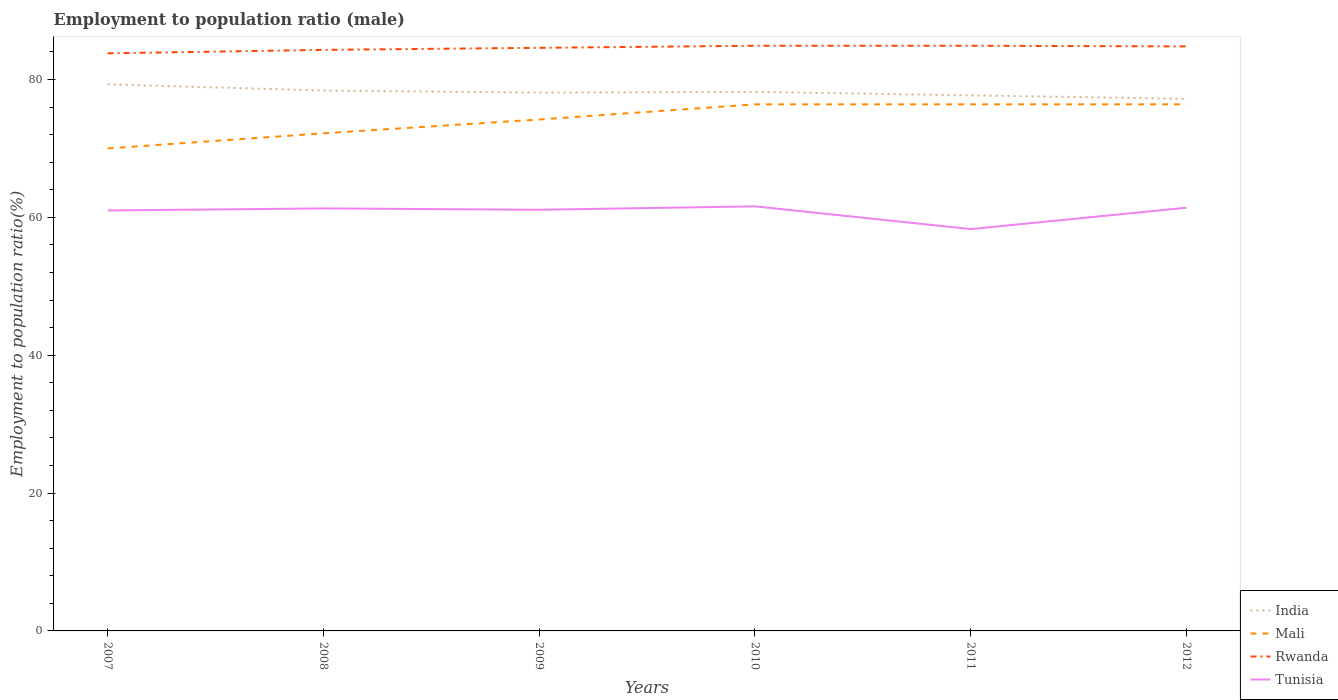How many different coloured lines are there?
Your answer should be very brief. 4. Across all years, what is the maximum employment to population ratio in Mali?
Offer a terse response. 70. In which year was the employment to population ratio in India maximum?
Give a very brief answer. 2012. What is the total employment to population ratio in India in the graph?
Offer a very short reply. 1.2. What is the difference between the highest and the second highest employment to population ratio in Mali?
Provide a short and direct response. 6.4. Is the employment to population ratio in Mali strictly greater than the employment to population ratio in India over the years?
Give a very brief answer. Yes. What is the difference between two consecutive major ticks on the Y-axis?
Your answer should be compact. 20. Are the values on the major ticks of Y-axis written in scientific E-notation?
Give a very brief answer. No. Does the graph contain any zero values?
Provide a succinct answer. No. Does the graph contain grids?
Provide a short and direct response. No. Where does the legend appear in the graph?
Provide a short and direct response. Bottom right. What is the title of the graph?
Your answer should be compact. Employment to population ratio (male). What is the label or title of the X-axis?
Offer a very short reply. Years. What is the Employment to population ratio(%) of India in 2007?
Ensure brevity in your answer.  79.3. What is the Employment to population ratio(%) of Rwanda in 2007?
Provide a succinct answer. 83.8. What is the Employment to population ratio(%) of India in 2008?
Make the answer very short. 78.4. What is the Employment to population ratio(%) of Mali in 2008?
Offer a terse response. 72.2. What is the Employment to population ratio(%) of Rwanda in 2008?
Give a very brief answer. 84.3. What is the Employment to population ratio(%) of Tunisia in 2008?
Give a very brief answer. 61.3. What is the Employment to population ratio(%) in India in 2009?
Your answer should be very brief. 78.1. What is the Employment to population ratio(%) of Mali in 2009?
Keep it short and to the point. 74.2. What is the Employment to population ratio(%) of Rwanda in 2009?
Give a very brief answer. 84.6. What is the Employment to population ratio(%) in Tunisia in 2009?
Offer a terse response. 61.1. What is the Employment to population ratio(%) of India in 2010?
Give a very brief answer. 78.2. What is the Employment to population ratio(%) of Mali in 2010?
Offer a terse response. 76.4. What is the Employment to population ratio(%) of Rwanda in 2010?
Keep it short and to the point. 84.9. What is the Employment to population ratio(%) in Tunisia in 2010?
Make the answer very short. 61.6. What is the Employment to population ratio(%) of India in 2011?
Offer a very short reply. 77.7. What is the Employment to population ratio(%) in Mali in 2011?
Your answer should be very brief. 76.4. What is the Employment to population ratio(%) of Rwanda in 2011?
Offer a terse response. 84.9. What is the Employment to population ratio(%) of Tunisia in 2011?
Make the answer very short. 58.3. What is the Employment to population ratio(%) in India in 2012?
Keep it short and to the point. 77.2. What is the Employment to population ratio(%) in Mali in 2012?
Your response must be concise. 76.4. What is the Employment to population ratio(%) in Rwanda in 2012?
Make the answer very short. 84.8. What is the Employment to population ratio(%) in Tunisia in 2012?
Offer a terse response. 61.4. Across all years, what is the maximum Employment to population ratio(%) of India?
Your response must be concise. 79.3. Across all years, what is the maximum Employment to population ratio(%) of Mali?
Your answer should be very brief. 76.4. Across all years, what is the maximum Employment to population ratio(%) of Rwanda?
Offer a very short reply. 84.9. Across all years, what is the maximum Employment to population ratio(%) in Tunisia?
Give a very brief answer. 61.6. Across all years, what is the minimum Employment to population ratio(%) in India?
Make the answer very short. 77.2. Across all years, what is the minimum Employment to population ratio(%) in Mali?
Ensure brevity in your answer.  70. Across all years, what is the minimum Employment to population ratio(%) of Rwanda?
Offer a terse response. 83.8. Across all years, what is the minimum Employment to population ratio(%) in Tunisia?
Give a very brief answer. 58.3. What is the total Employment to population ratio(%) in India in the graph?
Offer a very short reply. 468.9. What is the total Employment to population ratio(%) in Mali in the graph?
Make the answer very short. 445.6. What is the total Employment to population ratio(%) in Rwanda in the graph?
Offer a terse response. 507.3. What is the total Employment to population ratio(%) in Tunisia in the graph?
Your answer should be compact. 364.7. What is the difference between the Employment to population ratio(%) of Mali in 2007 and that in 2008?
Provide a succinct answer. -2.2. What is the difference between the Employment to population ratio(%) in Tunisia in 2007 and that in 2008?
Offer a very short reply. -0.3. What is the difference between the Employment to population ratio(%) in India in 2007 and that in 2009?
Offer a very short reply. 1.2. What is the difference between the Employment to population ratio(%) in Tunisia in 2007 and that in 2009?
Give a very brief answer. -0.1. What is the difference between the Employment to population ratio(%) of India in 2007 and that in 2010?
Your response must be concise. 1.1. What is the difference between the Employment to population ratio(%) of Mali in 2007 and that in 2010?
Give a very brief answer. -6.4. What is the difference between the Employment to population ratio(%) of Rwanda in 2007 and that in 2010?
Your answer should be very brief. -1.1. What is the difference between the Employment to population ratio(%) of India in 2007 and that in 2011?
Keep it short and to the point. 1.6. What is the difference between the Employment to population ratio(%) in Mali in 2007 and that in 2011?
Give a very brief answer. -6.4. What is the difference between the Employment to population ratio(%) of Rwanda in 2007 and that in 2011?
Your answer should be very brief. -1.1. What is the difference between the Employment to population ratio(%) of Mali in 2007 and that in 2012?
Provide a succinct answer. -6.4. What is the difference between the Employment to population ratio(%) of India in 2008 and that in 2009?
Offer a very short reply. 0.3. What is the difference between the Employment to population ratio(%) in India in 2008 and that in 2010?
Offer a very short reply. 0.2. What is the difference between the Employment to population ratio(%) of Mali in 2008 and that in 2010?
Your response must be concise. -4.2. What is the difference between the Employment to population ratio(%) in Rwanda in 2008 and that in 2010?
Your response must be concise. -0.6. What is the difference between the Employment to population ratio(%) in Tunisia in 2008 and that in 2010?
Make the answer very short. -0.3. What is the difference between the Employment to population ratio(%) in Rwanda in 2008 and that in 2011?
Offer a very short reply. -0.6. What is the difference between the Employment to population ratio(%) in India in 2008 and that in 2012?
Ensure brevity in your answer.  1.2. What is the difference between the Employment to population ratio(%) of Rwanda in 2008 and that in 2012?
Ensure brevity in your answer.  -0.5. What is the difference between the Employment to population ratio(%) in Mali in 2009 and that in 2010?
Provide a succinct answer. -2.2. What is the difference between the Employment to population ratio(%) in Rwanda in 2009 and that in 2010?
Keep it short and to the point. -0.3. What is the difference between the Employment to population ratio(%) in Tunisia in 2009 and that in 2010?
Make the answer very short. -0.5. What is the difference between the Employment to population ratio(%) in Mali in 2009 and that in 2011?
Ensure brevity in your answer.  -2.2. What is the difference between the Employment to population ratio(%) in Tunisia in 2009 and that in 2012?
Provide a succinct answer. -0.3. What is the difference between the Employment to population ratio(%) of India in 2010 and that in 2011?
Offer a terse response. 0.5. What is the difference between the Employment to population ratio(%) in Mali in 2010 and that in 2011?
Keep it short and to the point. 0. What is the difference between the Employment to population ratio(%) of Rwanda in 2010 and that in 2011?
Offer a terse response. 0. What is the difference between the Employment to population ratio(%) in Tunisia in 2010 and that in 2012?
Your response must be concise. 0.2. What is the difference between the Employment to population ratio(%) in India in 2011 and that in 2012?
Keep it short and to the point. 0.5. What is the difference between the Employment to population ratio(%) in Mali in 2011 and that in 2012?
Offer a terse response. 0. What is the difference between the Employment to population ratio(%) in Rwanda in 2011 and that in 2012?
Offer a terse response. 0.1. What is the difference between the Employment to population ratio(%) of Tunisia in 2011 and that in 2012?
Your answer should be compact. -3.1. What is the difference between the Employment to population ratio(%) of Mali in 2007 and the Employment to population ratio(%) of Rwanda in 2008?
Ensure brevity in your answer.  -14.3. What is the difference between the Employment to population ratio(%) in Mali in 2007 and the Employment to population ratio(%) in Tunisia in 2008?
Make the answer very short. 8.7. What is the difference between the Employment to population ratio(%) of Rwanda in 2007 and the Employment to population ratio(%) of Tunisia in 2008?
Ensure brevity in your answer.  22.5. What is the difference between the Employment to population ratio(%) in India in 2007 and the Employment to population ratio(%) in Mali in 2009?
Ensure brevity in your answer.  5.1. What is the difference between the Employment to population ratio(%) of Mali in 2007 and the Employment to population ratio(%) of Rwanda in 2009?
Offer a terse response. -14.6. What is the difference between the Employment to population ratio(%) in Rwanda in 2007 and the Employment to population ratio(%) in Tunisia in 2009?
Make the answer very short. 22.7. What is the difference between the Employment to population ratio(%) in India in 2007 and the Employment to population ratio(%) in Rwanda in 2010?
Provide a short and direct response. -5.6. What is the difference between the Employment to population ratio(%) in Mali in 2007 and the Employment to population ratio(%) in Rwanda in 2010?
Offer a very short reply. -14.9. What is the difference between the Employment to population ratio(%) of India in 2007 and the Employment to population ratio(%) of Mali in 2011?
Ensure brevity in your answer.  2.9. What is the difference between the Employment to population ratio(%) of Mali in 2007 and the Employment to population ratio(%) of Rwanda in 2011?
Make the answer very short. -14.9. What is the difference between the Employment to population ratio(%) of Mali in 2007 and the Employment to population ratio(%) of Tunisia in 2011?
Offer a very short reply. 11.7. What is the difference between the Employment to population ratio(%) of India in 2007 and the Employment to population ratio(%) of Rwanda in 2012?
Provide a short and direct response. -5.5. What is the difference between the Employment to population ratio(%) in Mali in 2007 and the Employment to population ratio(%) in Rwanda in 2012?
Offer a very short reply. -14.8. What is the difference between the Employment to population ratio(%) in Rwanda in 2007 and the Employment to population ratio(%) in Tunisia in 2012?
Provide a short and direct response. 22.4. What is the difference between the Employment to population ratio(%) in India in 2008 and the Employment to population ratio(%) in Mali in 2009?
Your answer should be compact. 4.2. What is the difference between the Employment to population ratio(%) of India in 2008 and the Employment to population ratio(%) of Rwanda in 2009?
Keep it short and to the point. -6.2. What is the difference between the Employment to population ratio(%) of Rwanda in 2008 and the Employment to population ratio(%) of Tunisia in 2009?
Ensure brevity in your answer.  23.2. What is the difference between the Employment to population ratio(%) of India in 2008 and the Employment to population ratio(%) of Tunisia in 2010?
Make the answer very short. 16.8. What is the difference between the Employment to population ratio(%) of Mali in 2008 and the Employment to population ratio(%) of Rwanda in 2010?
Your answer should be compact. -12.7. What is the difference between the Employment to population ratio(%) in Mali in 2008 and the Employment to population ratio(%) in Tunisia in 2010?
Make the answer very short. 10.6. What is the difference between the Employment to population ratio(%) in Rwanda in 2008 and the Employment to population ratio(%) in Tunisia in 2010?
Give a very brief answer. 22.7. What is the difference between the Employment to population ratio(%) in India in 2008 and the Employment to population ratio(%) in Mali in 2011?
Your answer should be compact. 2. What is the difference between the Employment to population ratio(%) of India in 2008 and the Employment to population ratio(%) of Tunisia in 2011?
Your answer should be very brief. 20.1. What is the difference between the Employment to population ratio(%) in Mali in 2008 and the Employment to population ratio(%) in Rwanda in 2011?
Provide a short and direct response. -12.7. What is the difference between the Employment to population ratio(%) of Rwanda in 2008 and the Employment to population ratio(%) of Tunisia in 2011?
Your answer should be very brief. 26. What is the difference between the Employment to population ratio(%) in India in 2008 and the Employment to population ratio(%) in Tunisia in 2012?
Provide a short and direct response. 17. What is the difference between the Employment to population ratio(%) in Mali in 2008 and the Employment to population ratio(%) in Rwanda in 2012?
Keep it short and to the point. -12.6. What is the difference between the Employment to population ratio(%) in Mali in 2008 and the Employment to population ratio(%) in Tunisia in 2012?
Your response must be concise. 10.8. What is the difference between the Employment to population ratio(%) of Rwanda in 2008 and the Employment to population ratio(%) of Tunisia in 2012?
Make the answer very short. 22.9. What is the difference between the Employment to population ratio(%) of India in 2009 and the Employment to population ratio(%) of Rwanda in 2010?
Offer a terse response. -6.8. What is the difference between the Employment to population ratio(%) of Mali in 2009 and the Employment to population ratio(%) of Rwanda in 2010?
Provide a succinct answer. -10.7. What is the difference between the Employment to population ratio(%) of Mali in 2009 and the Employment to population ratio(%) of Tunisia in 2010?
Make the answer very short. 12.6. What is the difference between the Employment to population ratio(%) in India in 2009 and the Employment to population ratio(%) in Mali in 2011?
Your response must be concise. 1.7. What is the difference between the Employment to population ratio(%) of India in 2009 and the Employment to population ratio(%) of Tunisia in 2011?
Ensure brevity in your answer.  19.8. What is the difference between the Employment to population ratio(%) in Mali in 2009 and the Employment to population ratio(%) in Rwanda in 2011?
Make the answer very short. -10.7. What is the difference between the Employment to population ratio(%) of Rwanda in 2009 and the Employment to population ratio(%) of Tunisia in 2011?
Your response must be concise. 26.3. What is the difference between the Employment to population ratio(%) of India in 2009 and the Employment to population ratio(%) of Tunisia in 2012?
Keep it short and to the point. 16.7. What is the difference between the Employment to population ratio(%) of Rwanda in 2009 and the Employment to population ratio(%) of Tunisia in 2012?
Provide a short and direct response. 23.2. What is the difference between the Employment to population ratio(%) in India in 2010 and the Employment to population ratio(%) in Mali in 2011?
Make the answer very short. 1.8. What is the difference between the Employment to population ratio(%) in India in 2010 and the Employment to population ratio(%) in Rwanda in 2011?
Give a very brief answer. -6.7. What is the difference between the Employment to population ratio(%) in India in 2010 and the Employment to population ratio(%) in Tunisia in 2011?
Ensure brevity in your answer.  19.9. What is the difference between the Employment to population ratio(%) of Mali in 2010 and the Employment to population ratio(%) of Tunisia in 2011?
Provide a succinct answer. 18.1. What is the difference between the Employment to population ratio(%) of Rwanda in 2010 and the Employment to population ratio(%) of Tunisia in 2011?
Offer a terse response. 26.6. What is the difference between the Employment to population ratio(%) of India in 2010 and the Employment to population ratio(%) of Mali in 2012?
Your response must be concise. 1.8. What is the difference between the Employment to population ratio(%) of India in 2010 and the Employment to population ratio(%) of Rwanda in 2012?
Provide a short and direct response. -6.6. What is the difference between the Employment to population ratio(%) of India in 2010 and the Employment to population ratio(%) of Tunisia in 2012?
Your answer should be compact. 16.8. What is the difference between the Employment to population ratio(%) of Rwanda in 2010 and the Employment to population ratio(%) of Tunisia in 2012?
Offer a very short reply. 23.5. What is the difference between the Employment to population ratio(%) of India in 2011 and the Employment to population ratio(%) of Tunisia in 2012?
Your answer should be very brief. 16.3. What is the average Employment to population ratio(%) in India per year?
Ensure brevity in your answer.  78.15. What is the average Employment to population ratio(%) of Mali per year?
Keep it short and to the point. 74.27. What is the average Employment to population ratio(%) of Rwanda per year?
Your answer should be very brief. 84.55. What is the average Employment to population ratio(%) in Tunisia per year?
Your answer should be compact. 60.78. In the year 2007, what is the difference between the Employment to population ratio(%) in India and Employment to population ratio(%) in Rwanda?
Your answer should be very brief. -4.5. In the year 2007, what is the difference between the Employment to population ratio(%) of Mali and Employment to population ratio(%) of Tunisia?
Ensure brevity in your answer.  9. In the year 2007, what is the difference between the Employment to population ratio(%) of Rwanda and Employment to population ratio(%) of Tunisia?
Your response must be concise. 22.8. In the year 2008, what is the difference between the Employment to population ratio(%) of India and Employment to population ratio(%) of Rwanda?
Your response must be concise. -5.9. In the year 2008, what is the difference between the Employment to population ratio(%) in India and Employment to population ratio(%) in Tunisia?
Keep it short and to the point. 17.1. In the year 2008, what is the difference between the Employment to population ratio(%) in Mali and Employment to population ratio(%) in Rwanda?
Your answer should be compact. -12.1. In the year 2008, what is the difference between the Employment to population ratio(%) of Rwanda and Employment to population ratio(%) of Tunisia?
Give a very brief answer. 23. In the year 2009, what is the difference between the Employment to population ratio(%) in India and Employment to population ratio(%) in Mali?
Ensure brevity in your answer.  3.9. In the year 2009, what is the difference between the Employment to population ratio(%) of India and Employment to population ratio(%) of Rwanda?
Your response must be concise. -6.5. In the year 2009, what is the difference between the Employment to population ratio(%) in Mali and Employment to population ratio(%) in Tunisia?
Provide a short and direct response. 13.1. In the year 2010, what is the difference between the Employment to population ratio(%) of Mali and Employment to population ratio(%) of Rwanda?
Make the answer very short. -8.5. In the year 2010, what is the difference between the Employment to population ratio(%) in Mali and Employment to population ratio(%) in Tunisia?
Your answer should be compact. 14.8. In the year 2010, what is the difference between the Employment to population ratio(%) in Rwanda and Employment to population ratio(%) in Tunisia?
Offer a very short reply. 23.3. In the year 2011, what is the difference between the Employment to population ratio(%) of Mali and Employment to population ratio(%) of Rwanda?
Your response must be concise. -8.5. In the year 2011, what is the difference between the Employment to population ratio(%) of Mali and Employment to population ratio(%) of Tunisia?
Your answer should be compact. 18.1. In the year 2011, what is the difference between the Employment to population ratio(%) in Rwanda and Employment to population ratio(%) in Tunisia?
Your response must be concise. 26.6. In the year 2012, what is the difference between the Employment to population ratio(%) in India and Employment to population ratio(%) in Mali?
Provide a succinct answer. 0.8. In the year 2012, what is the difference between the Employment to population ratio(%) of India and Employment to population ratio(%) of Rwanda?
Make the answer very short. -7.6. In the year 2012, what is the difference between the Employment to population ratio(%) in Rwanda and Employment to population ratio(%) in Tunisia?
Provide a succinct answer. 23.4. What is the ratio of the Employment to population ratio(%) of India in 2007 to that in 2008?
Ensure brevity in your answer.  1.01. What is the ratio of the Employment to population ratio(%) of Mali in 2007 to that in 2008?
Offer a terse response. 0.97. What is the ratio of the Employment to population ratio(%) of India in 2007 to that in 2009?
Your answer should be compact. 1.02. What is the ratio of the Employment to population ratio(%) in Mali in 2007 to that in 2009?
Offer a very short reply. 0.94. What is the ratio of the Employment to population ratio(%) of Rwanda in 2007 to that in 2009?
Give a very brief answer. 0.99. What is the ratio of the Employment to population ratio(%) in Tunisia in 2007 to that in 2009?
Give a very brief answer. 1. What is the ratio of the Employment to population ratio(%) of India in 2007 to that in 2010?
Provide a short and direct response. 1.01. What is the ratio of the Employment to population ratio(%) in Mali in 2007 to that in 2010?
Offer a very short reply. 0.92. What is the ratio of the Employment to population ratio(%) in Rwanda in 2007 to that in 2010?
Ensure brevity in your answer.  0.99. What is the ratio of the Employment to population ratio(%) in Tunisia in 2007 to that in 2010?
Offer a terse response. 0.99. What is the ratio of the Employment to population ratio(%) of India in 2007 to that in 2011?
Give a very brief answer. 1.02. What is the ratio of the Employment to population ratio(%) of Mali in 2007 to that in 2011?
Offer a very short reply. 0.92. What is the ratio of the Employment to population ratio(%) of Tunisia in 2007 to that in 2011?
Ensure brevity in your answer.  1.05. What is the ratio of the Employment to population ratio(%) of India in 2007 to that in 2012?
Offer a very short reply. 1.03. What is the ratio of the Employment to population ratio(%) of Mali in 2007 to that in 2012?
Your answer should be compact. 0.92. What is the ratio of the Employment to population ratio(%) in Tunisia in 2008 to that in 2009?
Make the answer very short. 1. What is the ratio of the Employment to population ratio(%) of Mali in 2008 to that in 2010?
Give a very brief answer. 0.94. What is the ratio of the Employment to population ratio(%) of Rwanda in 2008 to that in 2010?
Offer a very short reply. 0.99. What is the ratio of the Employment to population ratio(%) of India in 2008 to that in 2011?
Ensure brevity in your answer.  1.01. What is the ratio of the Employment to population ratio(%) of Mali in 2008 to that in 2011?
Provide a short and direct response. 0.94. What is the ratio of the Employment to population ratio(%) in Tunisia in 2008 to that in 2011?
Give a very brief answer. 1.05. What is the ratio of the Employment to population ratio(%) of India in 2008 to that in 2012?
Your answer should be compact. 1.02. What is the ratio of the Employment to population ratio(%) in Mali in 2008 to that in 2012?
Your answer should be compact. 0.94. What is the ratio of the Employment to population ratio(%) of India in 2009 to that in 2010?
Offer a terse response. 1. What is the ratio of the Employment to population ratio(%) of Mali in 2009 to that in 2010?
Give a very brief answer. 0.97. What is the ratio of the Employment to population ratio(%) in Rwanda in 2009 to that in 2010?
Provide a short and direct response. 1. What is the ratio of the Employment to population ratio(%) of Tunisia in 2009 to that in 2010?
Your answer should be very brief. 0.99. What is the ratio of the Employment to population ratio(%) of India in 2009 to that in 2011?
Ensure brevity in your answer.  1.01. What is the ratio of the Employment to population ratio(%) of Mali in 2009 to that in 2011?
Your answer should be very brief. 0.97. What is the ratio of the Employment to population ratio(%) in Tunisia in 2009 to that in 2011?
Ensure brevity in your answer.  1.05. What is the ratio of the Employment to population ratio(%) in India in 2009 to that in 2012?
Make the answer very short. 1.01. What is the ratio of the Employment to population ratio(%) of Mali in 2009 to that in 2012?
Your response must be concise. 0.97. What is the ratio of the Employment to population ratio(%) of India in 2010 to that in 2011?
Your answer should be very brief. 1.01. What is the ratio of the Employment to population ratio(%) in Mali in 2010 to that in 2011?
Provide a succinct answer. 1. What is the ratio of the Employment to population ratio(%) of Tunisia in 2010 to that in 2011?
Ensure brevity in your answer.  1.06. What is the ratio of the Employment to population ratio(%) of Rwanda in 2010 to that in 2012?
Your answer should be compact. 1. What is the ratio of the Employment to population ratio(%) in India in 2011 to that in 2012?
Provide a short and direct response. 1.01. What is the ratio of the Employment to population ratio(%) in Rwanda in 2011 to that in 2012?
Provide a succinct answer. 1. What is the ratio of the Employment to population ratio(%) in Tunisia in 2011 to that in 2012?
Provide a succinct answer. 0.95. What is the difference between the highest and the second highest Employment to population ratio(%) of India?
Your answer should be very brief. 0.9. What is the difference between the highest and the second highest Employment to population ratio(%) in Rwanda?
Keep it short and to the point. 0. What is the difference between the highest and the second highest Employment to population ratio(%) of Tunisia?
Your answer should be compact. 0.2. What is the difference between the highest and the lowest Employment to population ratio(%) in Mali?
Give a very brief answer. 6.4. What is the difference between the highest and the lowest Employment to population ratio(%) in Rwanda?
Offer a very short reply. 1.1. What is the difference between the highest and the lowest Employment to population ratio(%) in Tunisia?
Your response must be concise. 3.3. 